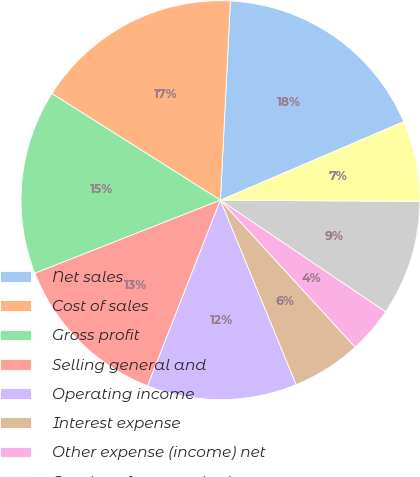Convert chart to OTSL. <chart><loc_0><loc_0><loc_500><loc_500><pie_chart><fcel>Net sales<fcel>Cost of sales<fcel>Gross profit<fcel>Selling general and<fcel>Operating income<fcel>Interest expense<fcel>Other expense (income) net<fcel>Earnings from continuing<fcel>Income tax expense<nl><fcel>17.76%<fcel>16.82%<fcel>14.95%<fcel>13.08%<fcel>12.15%<fcel>5.61%<fcel>3.74%<fcel>9.35%<fcel>6.54%<nl></chart> 